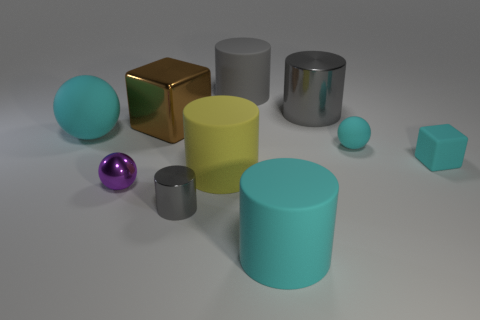Subtract all blue balls. How many gray cylinders are left? 3 Subtract all cyan cylinders. How many cylinders are left? 4 Subtract all tiny cylinders. How many cylinders are left? 4 Subtract all purple cylinders. Subtract all green blocks. How many cylinders are left? 5 Subtract all cubes. How many objects are left? 8 Add 3 purple metallic balls. How many purple metallic balls are left? 4 Add 8 purple metal objects. How many purple metal objects exist? 9 Subtract 0 red cubes. How many objects are left? 10 Subtract all tiny gray cylinders. Subtract all small gray objects. How many objects are left? 8 